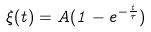<formula> <loc_0><loc_0><loc_500><loc_500>\xi ( t ) = A ( 1 - e ^ { - \frac { t } { \tau } } )</formula> 